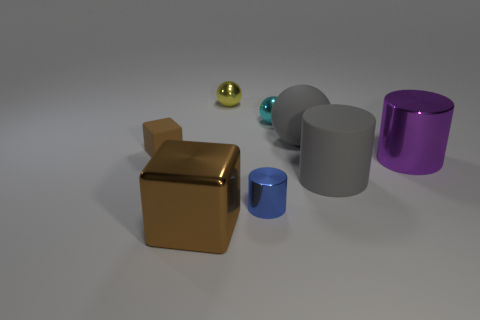Does the large ball have the same material as the block that is behind the blue metallic object?
Offer a very short reply. Yes. Are there more large gray rubber balls that are on the right side of the big purple metal cylinder than matte cylinders that are left of the large gray rubber cylinder?
Offer a terse response. No. What is the shape of the large brown thing?
Ensure brevity in your answer.  Cube. Is the small ball that is in front of the small yellow shiny ball made of the same material as the big thing that is left of the yellow thing?
Provide a succinct answer. Yes. There is a big matte thing in front of the gray matte ball; what is its shape?
Provide a succinct answer. Cylinder. There is another brown thing that is the same shape as the tiny matte object; what is its size?
Your answer should be very brief. Large. Do the big rubber ball and the small rubber object have the same color?
Your response must be concise. No. Is there any other thing that is the same shape as the tiny matte object?
Give a very brief answer. Yes. Are there any large brown metallic objects on the right side of the small ball behind the cyan shiny ball?
Ensure brevity in your answer.  No. There is another rubber thing that is the same shape as the purple object; what color is it?
Ensure brevity in your answer.  Gray. 